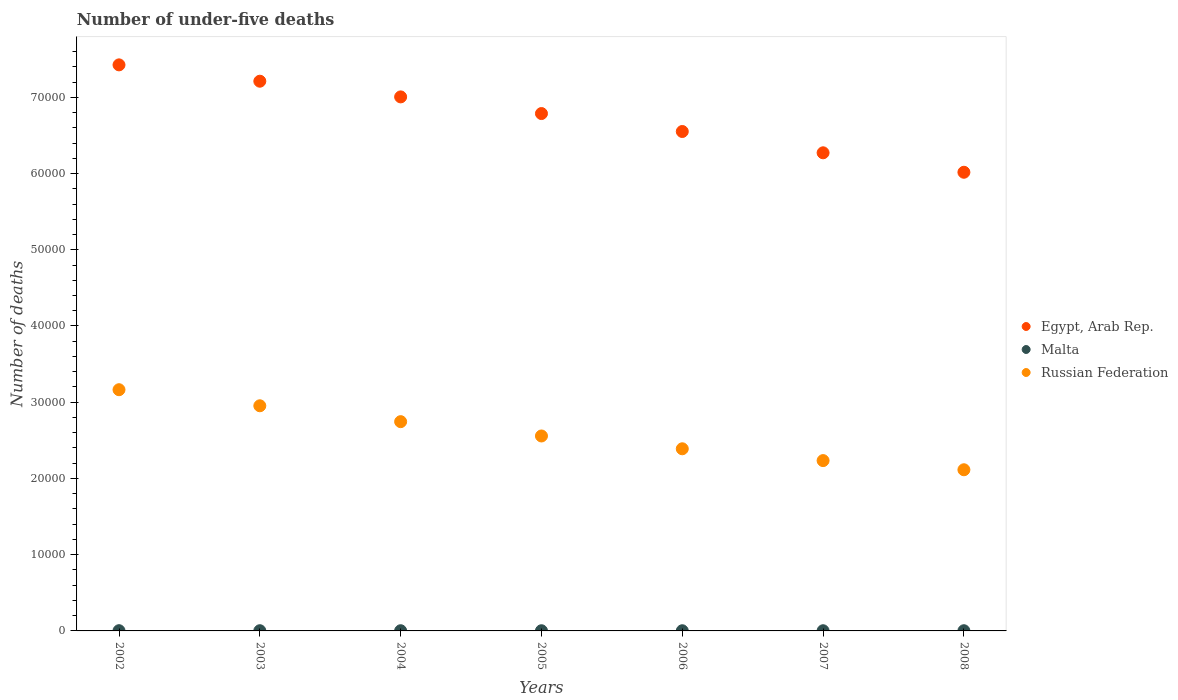How many different coloured dotlines are there?
Give a very brief answer. 3. What is the number of under-five deaths in Malta in 2007?
Make the answer very short. 24. Across all years, what is the maximum number of under-five deaths in Malta?
Your answer should be very brief. 31. Across all years, what is the minimum number of under-five deaths in Russian Federation?
Your response must be concise. 2.11e+04. In which year was the number of under-five deaths in Malta minimum?
Make the answer very short. 2006. What is the total number of under-five deaths in Malta in the graph?
Give a very brief answer. 180. What is the difference between the number of under-five deaths in Malta in 2003 and that in 2007?
Keep it short and to the point. 4. What is the difference between the number of under-five deaths in Egypt, Arab Rep. in 2002 and the number of under-five deaths in Russian Federation in 2007?
Make the answer very short. 5.19e+04. What is the average number of under-five deaths in Malta per year?
Keep it short and to the point. 25.71. In the year 2008, what is the difference between the number of under-five deaths in Malta and number of under-five deaths in Egypt, Arab Rep.?
Offer a terse response. -6.01e+04. What is the ratio of the number of under-five deaths in Malta in 2004 to that in 2007?
Ensure brevity in your answer.  1.04. What is the difference between the highest and the lowest number of under-five deaths in Egypt, Arab Rep.?
Provide a succinct answer. 1.41e+04. In how many years, is the number of under-five deaths in Egypt, Arab Rep. greater than the average number of under-five deaths in Egypt, Arab Rep. taken over all years?
Keep it short and to the point. 4. Does the number of under-five deaths in Malta monotonically increase over the years?
Keep it short and to the point. No. Is the number of under-five deaths in Malta strictly greater than the number of under-five deaths in Egypt, Arab Rep. over the years?
Ensure brevity in your answer.  No. Is the number of under-five deaths in Egypt, Arab Rep. strictly less than the number of under-five deaths in Malta over the years?
Your answer should be compact. No. What is the difference between two consecutive major ticks on the Y-axis?
Offer a very short reply. 10000. Are the values on the major ticks of Y-axis written in scientific E-notation?
Provide a short and direct response. No. Where does the legend appear in the graph?
Offer a very short reply. Center right. What is the title of the graph?
Offer a terse response. Number of under-five deaths. What is the label or title of the Y-axis?
Make the answer very short. Number of deaths. What is the Number of deaths in Egypt, Arab Rep. in 2002?
Offer a very short reply. 7.43e+04. What is the Number of deaths in Malta in 2002?
Provide a succinct answer. 31. What is the Number of deaths in Russian Federation in 2002?
Offer a very short reply. 3.16e+04. What is the Number of deaths in Egypt, Arab Rep. in 2003?
Make the answer very short. 7.21e+04. What is the Number of deaths of Russian Federation in 2003?
Keep it short and to the point. 2.95e+04. What is the Number of deaths in Egypt, Arab Rep. in 2004?
Keep it short and to the point. 7.01e+04. What is the Number of deaths in Malta in 2004?
Make the answer very short. 25. What is the Number of deaths in Russian Federation in 2004?
Offer a very short reply. 2.75e+04. What is the Number of deaths of Egypt, Arab Rep. in 2005?
Give a very brief answer. 6.79e+04. What is the Number of deaths of Malta in 2005?
Provide a succinct answer. 24. What is the Number of deaths in Russian Federation in 2005?
Provide a succinct answer. 2.56e+04. What is the Number of deaths of Egypt, Arab Rep. in 2006?
Your response must be concise. 6.55e+04. What is the Number of deaths in Russian Federation in 2006?
Keep it short and to the point. 2.39e+04. What is the Number of deaths of Egypt, Arab Rep. in 2007?
Your answer should be very brief. 6.27e+04. What is the Number of deaths in Russian Federation in 2007?
Keep it short and to the point. 2.23e+04. What is the Number of deaths of Egypt, Arab Rep. in 2008?
Your answer should be very brief. 6.02e+04. What is the Number of deaths of Russian Federation in 2008?
Your response must be concise. 2.11e+04. Across all years, what is the maximum Number of deaths in Egypt, Arab Rep.?
Keep it short and to the point. 7.43e+04. Across all years, what is the maximum Number of deaths of Russian Federation?
Offer a terse response. 3.16e+04. Across all years, what is the minimum Number of deaths of Egypt, Arab Rep.?
Make the answer very short. 6.02e+04. Across all years, what is the minimum Number of deaths in Russian Federation?
Keep it short and to the point. 2.11e+04. What is the total Number of deaths of Egypt, Arab Rep. in the graph?
Keep it short and to the point. 4.73e+05. What is the total Number of deaths of Malta in the graph?
Provide a succinct answer. 180. What is the total Number of deaths in Russian Federation in the graph?
Offer a terse response. 1.82e+05. What is the difference between the Number of deaths of Egypt, Arab Rep. in 2002 and that in 2003?
Keep it short and to the point. 2144. What is the difference between the Number of deaths in Russian Federation in 2002 and that in 2003?
Your answer should be very brief. 2108. What is the difference between the Number of deaths in Egypt, Arab Rep. in 2002 and that in 2004?
Your answer should be compact. 4201. What is the difference between the Number of deaths in Russian Federation in 2002 and that in 2004?
Your response must be concise. 4191. What is the difference between the Number of deaths of Egypt, Arab Rep. in 2002 and that in 2005?
Your answer should be compact. 6386. What is the difference between the Number of deaths of Malta in 2002 and that in 2005?
Provide a short and direct response. 7. What is the difference between the Number of deaths in Russian Federation in 2002 and that in 2005?
Give a very brief answer. 6069. What is the difference between the Number of deaths in Egypt, Arab Rep. in 2002 and that in 2006?
Your response must be concise. 8741. What is the difference between the Number of deaths in Russian Federation in 2002 and that in 2006?
Your answer should be compact. 7749. What is the difference between the Number of deaths of Egypt, Arab Rep. in 2002 and that in 2007?
Give a very brief answer. 1.15e+04. What is the difference between the Number of deaths in Malta in 2002 and that in 2007?
Offer a very short reply. 7. What is the difference between the Number of deaths in Russian Federation in 2002 and that in 2007?
Your response must be concise. 9299. What is the difference between the Number of deaths in Egypt, Arab Rep. in 2002 and that in 2008?
Provide a short and direct response. 1.41e+04. What is the difference between the Number of deaths in Russian Federation in 2002 and that in 2008?
Make the answer very short. 1.05e+04. What is the difference between the Number of deaths in Egypt, Arab Rep. in 2003 and that in 2004?
Provide a succinct answer. 2057. What is the difference between the Number of deaths in Russian Federation in 2003 and that in 2004?
Offer a terse response. 2083. What is the difference between the Number of deaths of Egypt, Arab Rep. in 2003 and that in 2005?
Provide a succinct answer. 4242. What is the difference between the Number of deaths in Russian Federation in 2003 and that in 2005?
Make the answer very short. 3961. What is the difference between the Number of deaths of Egypt, Arab Rep. in 2003 and that in 2006?
Offer a very short reply. 6597. What is the difference between the Number of deaths in Malta in 2003 and that in 2006?
Provide a short and direct response. 5. What is the difference between the Number of deaths in Russian Federation in 2003 and that in 2006?
Provide a succinct answer. 5641. What is the difference between the Number of deaths of Egypt, Arab Rep. in 2003 and that in 2007?
Your answer should be very brief. 9391. What is the difference between the Number of deaths of Malta in 2003 and that in 2007?
Give a very brief answer. 4. What is the difference between the Number of deaths in Russian Federation in 2003 and that in 2007?
Provide a succinct answer. 7191. What is the difference between the Number of deaths of Egypt, Arab Rep. in 2003 and that in 2008?
Your response must be concise. 1.19e+04. What is the difference between the Number of deaths in Russian Federation in 2003 and that in 2008?
Provide a succinct answer. 8393. What is the difference between the Number of deaths of Egypt, Arab Rep. in 2004 and that in 2005?
Your answer should be compact. 2185. What is the difference between the Number of deaths in Malta in 2004 and that in 2005?
Your response must be concise. 1. What is the difference between the Number of deaths in Russian Federation in 2004 and that in 2005?
Provide a short and direct response. 1878. What is the difference between the Number of deaths of Egypt, Arab Rep. in 2004 and that in 2006?
Your answer should be very brief. 4540. What is the difference between the Number of deaths in Russian Federation in 2004 and that in 2006?
Your answer should be compact. 3558. What is the difference between the Number of deaths in Egypt, Arab Rep. in 2004 and that in 2007?
Provide a short and direct response. 7334. What is the difference between the Number of deaths of Russian Federation in 2004 and that in 2007?
Offer a very short reply. 5108. What is the difference between the Number of deaths in Egypt, Arab Rep. in 2004 and that in 2008?
Your answer should be very brief. 9887. What is the difference between the Number of deaths in Malta in 2004 and that in 2008?
Your answer should be compact. 0. What is the difference between the Number of deaths of Russian Federation in 2004 and that in 2008?
Keep it short and to the point. 6310. What is the difference between the Number of deaths in Egypt, Arab Rep. in 2005 and that in 2006?
Your response must be concise. 2355. What is the difference between the Number of deaths of Russian Federation in 2005 and that in 2006?
Offer a terse response. 1680. What is the difference between the Number of deaths in Egypt, Arab Rep. in 2005 and that in 2007?
Offer a terse response. 5149. What is the difference between the Number of deaths of Malta in 2005 and that in 2007?
Give a very brief answer. 0. What is the difference between the Number of deaths in Russian Federation in 2005 and that in 2007?
Keep it short and to the point. 3230. What is the difference between the Number of deaths of Egypt, Arab Rep. in 2005 and that in 2008?
Make the answer very short. 7702. What is the difference between the Number of deaths in Russian Federation in 2005 and that in 2008?
Your response must be concise. 4432. What is the difference between the Number of deaths of Egypt, Arab Rep. in 2006 and that in 2007?
Your answer should be very brief. 2794. What is the difference between the Number of deaths of Malta in 2006 and that in 2007?
Offer a terse response. -1. What is the difference between the Number of deaths of Russian Federation in 2006 and that in 2007?
Offer a terse response. 1550. What is the difference between the Number of deaths of Egypt, Arab Rep. in 2006 and that in 2008?
Ensure brevity in your answer.  5347. What is the difference between the Number of deaths in Malta in 2006 and that in 2008?
Your answer should be compact. -2. What is the difference between the Number of deaths of Russian Federation in 2006 and that in 2008?
Give a very brief answer. 2752. What is the difference between the Number of deaths of Egypt, Arab Rep. in 2007 and that in 2008?
Your answer should be very brief. 2553. What is the difference between the Number of deaths of Russian Federation in 2007 and that in 2008?
Your response must be concise. 1202. What is the difference between the Number of deaths of Egypt, Arab Rep. in 2002 and the Number of deaths of Malta in 2003?
Keep it short and to the point. 7.42e+04. What is the difference between the Number of deaths of Egypt, Arab Rep. in 2002 and the Number of deaths of Russian Federation in 2003?
Offer a very short reply. 4.47e+04. What is the difference between the Number of deaths of Malta in 2002 and the Number of deaths of Russian Federation in 2003?
Provide a succinct answer. -2.95e+04. What is the difference between the Number of deaths in Egypt, Arab Rep. in 2002 and the Number of deaths in Malta in 2004?
Offer a very short reply. 7.42e+04. What is the difference between the Number of deaths of Egypt, Arab Rep. in 2002 and the Number of deaths of Russian Federation in 2004?
Keep it short and to the point. 4.68e+04. What is the difference between the Number of deaths of Malta in 2002 and the Number of deaths of Russian Federation in 2004?
Your response must be concise. -2.74e+04. What is the difference between the Number of deaths of Egypt, Arab Rep. in 2002 and the Number of deaths of Malta in 2005?
Offer a very short reply. 7.42e+04. What is the difference between the Number of deaths of Egypt, Arab Rep. in 2002 and the Number of deaths of Russian Federation in 2005?
Your response must be concise. 4.87e+04. What is the difference between the Number of deaths of Malta in 2002 and the Number of deaths of Russian Federation in 2005?
Give a very brief answer. -2.55e+04. What is the difference between the Number of deaths of Egypt, Arab Rep. in 2002 and the Number of deaths of Malta in 2006?
Offer a very short reply. 7.42e+04. What is the difference between the Number of deaths of Egypt, Arab Rep. in 2002 and the Number of deaths of Russian Federation in 2006?
Offer a terse response. 5.04e+04. What is the difference between the Number of deaths of Malta in 2002 and the Number of deaths of Russian Federation in 2006?
Your response must be concise. -2.39e+04. What is the difference between the Number of deaths in Egypt, Arab Rep. in 2002 and the Number of deaths in Malta in 2007?
Your response must be concise. 7.42e+04. What is the difference between the Number of deaths in Egypt, Arab Rep. in 2002 and the Number of deaths in Russian Federation in 2007?
Ensure brevity in your answer.  5.19e+04. What is the difference between the Number of deaths in Malta in 2002 and the Number of deaths in Russian Federation in 2007?
Offer a very short reply. -2.23e+04. What is the difference between the Number of deaths of Egypt, Arab Rep. in 2002 and the Number of deaths of Malta in 2008?
Your answer should be very brief. 7.42e+04. What is the difference between the Number of deaths of Egypt, Arab Rep. in 2002 and the Number of deaths of Russian Federation in 2008?
Your answer should be very brief. 5.31e+04. What is the difference between the Number of deaths in Malta in 2002 and the Number of deaths in Russian Federation in 2008?
Your answer should be compact. -2.11e+04. What is the difference between the Number of deaths of Egypt, Arab Rep. in 2003 and the Number of deaths of Malta in 2004?
Provide a short and direct response. 7.21e+04. What is the difference between the Number of deaths in Egypt, Arab Rep. in 2003 and the Number of deaths in Russian Federation in 2004?
Ensure brevity in your answer.  4.47e+04. What is the difference between the Number of deaths of Malta in 2003 and the Number of deaths of Russian Federation in 2004?
Offer a terse response. -2.74e+04. What is the difference between the Number of deaths of Egypt, Arab Rep. in 2003 and the Number of deaths of Malta in 2005?
Make the answer very short. 7.21e+04. What is the difference between the Number of deaths in Egypt, Arab Rep. in 2003 and the Number of deaths in Russian Federation in 2005?
Make the answer very short. 4.65e+04. What is the difference between the Number of deaths of Malta in 2003 and the Number of deaths of Russian Federation in 2005?
Your response must be concise. -2.55e+04. What is the difference between the Number of deaths of Egypt, Arab Rep. in 2003 and the Number of deaths of Malta in 2006?
Make the answer very short. 7.21e+04. What is the difference between the Number of deaths of Egypt, Arab Rep. in 2003 and the Number of deaths of Russian Federation in 2006?
Offer a very short reply. 4.82e+04. What is the difference between the Number of deaths in Malta in 2003 and the Number of deaths in Russian Federation in 2006?
Give a very brief answer. -2.39e+04. What is the difference between the Number of deaths in Egypt, Arab Rep. in 2003 and the Number of deaths in Malta in 2007?
Make the answer very short. 7.21e+04. What is the difference between the Number of deaths in Egypt, Arab Rep. in 2003 and the Number of deaths in Russian Federation in 2007?
Your response must be concise. 4.98e+04. What is the difference between the Number of deaths in Malta in 2003 and the Number of deaths in Russian Federation in 2007?
Provide a short and direct response. -2.23e+04. What is the difference between the Number of deaths of Egypt, Arab Rep. in 2003 and the Number of deaths of Malta in 2008?
Ensure brevity in your answer.  7.21e+04. What is the difference between the Number of deaths in Egypt, Arab Rep. in 2003 and the Number of deaths in Russian Federation in 2008?
Your response must be concise. 5.10e+04. What is the difference between the Number of deaths in Malta in 2003 and the Number of deaths in Russian Federation in 2008?
Ensure brevity in your answer.  -2.11e+04. What is the difference between the Number of deaths in Egypt, Arab Rep. in 2004 and the Number of deaths in Malta in 2005?
Give a very brief answer. 7.00e+04. What is the difference between the Number of deaths of Egypt, Arab Rep. in 2004 and the Number of deaths of Russian Federation in 2005?
Your answer should be very brief. 4.45e+04. What is the difference between the Number of deaths of Malta in 2004 and the Number of deaths of Russian Federation in 2005?
Your answer should be very brief. -2.55e+04. What is the difference between the Number of deaths of Egypt, Arab Rep. in 2004 and the Number of deaths of Malta in 2006?
Offer a very short reply. 7.00e+04. What is the difference between the Number of deaths in Egypt, Arab Rep. in 2004 and the Number of deaths in Russian Federation in 2006?
Make the answer very short. 4.62e+04. What is the difference between the Number of deaths in Malta in 2004 and the Number of deaths in Russian Federation in 2006?
Give a very brief answer. -2.39e+04. What is the difference between the Number of deaths of Egypt, Arab Rep. in 2004 and the Number of deaths of Malta in 2007?
Keep it short and to the point. 7.00e+04. What is the difference between the Number of deaths in Egypt, Arab Rep. in 2004 and the Number of deaths in Russian Federation in 2007?
Your answer should be very brief. 4.77e+04. What is the difference between the Number of deaths in Malta in 2004 and the Number of deaths in Russian Federation in 2007?
Your response must be concise. -2.23e+04. What is the difference between the Number of deaths of Egypt, Arab Rep. in 2004 and the Number of deaths of Malta in 2008?
Your answer should be compact. 7.00e+04. What is the difference between the Number of deaths of Egypt, Arab Rep. in 2004 and the Number of deaths of Russian Federation in 2008?
Offer a terse response. 4.89e+04. What is the difference between the Number of deaths in Malta in 2004 and the Number of deaths in Russian Federation in 2008?
Provide a succinct answer. -2.11e+04. What is the difference between the Number of deaths in Egypt, Arab Rep. in 2005 and the Number of deaths in Malta in 2006?
Give a very brief answer. 6.78e+04. What is the difference between the Number of deaths in Egypt, Arab Rep. in 2005 and the Number of deaths in Russian Federation in 2006?
Your answer should be compact. 4.40e+04. What is the difference between the Number of deaths of Malta in 2005 and the Number of deaths of Russian Federation in 2006?
Your answer should be compact. -2.39e+04. What is the difference between the Number of deaths of Egypt, Arab Rep. in 2005 and the Number of deaths of Malta in 2007?
Offer a very short reply. 6.78e+04. What is the difference between the Number of deaths of Egypt, Arab Rep. in 2005 and the Number of deaths of Russian Federation in 2007?
Keep it short and to the point. 4.55e+04. What is the difference between the Number of deaths of Malta in 2005 and the Number of deaths of Russian Federation in 2007?
Your response must be concise. -2.23e+04. What is the difference between the Number of deaths of Egypt, Arab Rep. in 2005 and the Number of deaths of Malta in 2008?
Provide a succinct answer. 6.78e+04. What is the difference between the Number of deaths of Egypt, Arab Rep. in 2005 and the Number of deaths of Russian Federation in 2008?
Offer a very short reply. 4.67e+04. What is the difference between the Number of deaths in Malta in 2005 and the Number of deaths in Russian Federation in 2008?
Offer a terse response. -2.11e+04. What is the difference between the Number of deaths in Egypt, Arab Rep. in 2006 and the Number of deaths in Malta in 2007?
Offer a very short reply. 6.55e+04. What is the difference between the Number of deaths in Egypt, Arab Rep. in 2006 and the Number of deaths in Russian Federation in 2007?
Offer a terse response. 4.32e+04. What is the difference between the Number of deaths of Malta in 2006 and the Number of deaths of Russian Federation in 2007?
Offer a very short reply. -2.23e+04. What is the difference between the Number of deaths of Egypt, Arab Rep. in 2006 and the Number of deaths of Malta in 2008?
Ensure brevity in your answer.  6.55e+04. What is the difference between the Number of deaths of Egypt, Arab Rep. in 2006 and the Number of deaths of Russian Federation in 2008?
Ensure brevity in your answer.  4.44e+04. What is the difference between the Number of deaths in Malta in 2006 and the Number of deaths in Russian Federation in 2008?
Provide a short and direct response. -2.11e+04. What is the difference between the Number of deaths of Egypt, Arab Rep. in 2007 and the Number of deaths of Malta in 2008?
Keep it short and to the point. 6.27e+04. What is the difference between the Number of deaths of Egypt, Arab Rep. in 2007 and the Number of deaths of Russian Federation in 2008?
Your answer should be compact. 4.16e+04. What is the difference between the Number of deaths of Malta in 2007 and the Number of deaths of Russian Federation in 2008?
Ensure brevity in your answer.  -2.11e+04. What is the average Number of deaths of Egypt, Arab Rep. per year?
Give a very brief answer. 6.75e+04. What is the average Number of deaths of Malta per year?
Make the answer very short. 25.71. What is the average Number of deaths in Russian Federation per year?
Provide a short and direct response. 2.59e+04. In the year 2002, what is the difference between the Number of deaths in Egypt, Arab Rep. and Number of deaths in Malta?
Provide a succinct answer. 7.42e+04. In the year 2002, what is the difference between the Number of deaths of Egypt, Arab Rep. and Number of deaths of Russian Federation?
Offer a terse response. 4.26e+04. In the year 2002, what is the difference between the Number of deaths of Malta and Number of deaths of Russian Federation?
Your response must be concise. -3.16e+04. In the year 2003, what is the difference between the Number of deaths of Egypt, Arab Rep. and Number of deaths of Malta?
Make the answer very short. 7.21e+04. In the year 2003, what is the difference between the Number of deaths in Egypt, Arab Rep. and Number of deaths in Russian Federation?
Your response must be concise. 4.26e+04. In the year 2003, what is the difference between the Number of deaths in Malta and Number of deaths in Russian Federation?
Your response must be concise. -2.95e+04. In the year 2004, what is the difference between the Number of deaths in Egypt, Arab Rep. and Number of deaths in Malta?
Keep it short and to the point. 7.00e+04. In the year 2004, what is the difference between the Number of deaths of Egypt, Arab Rep. and Number of deaths of Russian Federation?
Keep it short and to the point. 4.26e+04. In the year 2004, what is the difference between the Number of deaths in Malta and Number of deaths in Russian Federation?
Your answer should be compact. -2.74e+04. In the year 2005, what is the difference between the Number of deaths of Egypt, Arab Rep. and Number of deaths of Malta?
Offer a very short reply. 6.78e+04. In the year 2005, what is the difference between the Number of deaths in Egypt, Arab Rep. and Number of deaths in Russian Federation?
Offer a terse response. 4.23e+04. In the year 2005, what is the difference between the Number of deaths in Malta and Number of deaths in Russian Federation?
Your response must be concise. -2.55e+04. In the year 2006, what is the difference between the Number of deaths in Egypt, Arab Rep. and Number of deaths in Malta?
Your response must be concise. 6.55e+04. In the year 2006, what is the difference between the Number of deaths of Egypt, Arab Rep. and Number of deaths of Russian Federation?
Give a very brief answer. 4.16e+04. In the year 2006, what is the difference between the Number of deaths in Malta and Number of deaths in Russian Federation?
Keep it short and to the point. -2.39e+04. In the year 2007, what is the difference between the Number of deaths of Egypt, Arab Rep. and Number of deaths of Malta?
Offer a very short reply. 6.27e+04. In the year 2007, what is the difference between the Number of deaths in Egypt, Arab Rep. and Number of deaths in Russian Federation?
Make the answer very short. 4.04e+04. In the year 2007, what is the difference between the Number of deaths of Malta and Number of deaths of Russian Federation?
Your response must be concise. -2.23e+04. In the year 2008, what is the difference between the Number of deaths of Egypt, Arab Rep. and Number of deaths of Malta?
Make the answer very short. 6.01e+04. In the year 2008, what is the difference between the Number of deaths in Egypt, Arab Rep. and Number of deaths in Russian Federation?
Make the answer very short. 3.90e+04. In the year 2008, what is the difference between the Number of deaths in Malta and Number of deaths in Russian Federation?
Your answer should be very brief. -2.11e+04. What is the ratio of the Number of deaths of Egypt, Arab Rep. in 2002 to that in 2003?
Your response must be concise. 1.03. What is the ratio of the Number of deaths in Malta in 2002 to that in 2003?
Your answer should be very brief. 1.11. What is the ratio of the Number of deaths in Russian Federation in 2002 to that in 2003?
Ensure brevity in your answer.  1.07. What is the ratio of the Number of deaths of Egypt, Arab Rep. in 2002 to that in 2004?
Give a very brief answer. 1.06. What is the ratio of the Number of deaths of Malta in 2002 to that in 2004?
Provide a succinct answer. 1.24. What is the ratio of the Number of deaths in Russian Federation in 2002 to that in 2004?
Your response must be concise. 1.15. What is the ratio of the Number of deaths in Egypt, Arab Rep. in 2002 to that in 2005?
Give a very brief answer. 1.09. What is the ratio of the Number of deaths of Malta in 2002 to that in 2005?
Offer a terse response. 1.29. What is the ratio of the Number of deaths in Russian Federation in 2002 to that in 2005?
Provide a succinct answer. 1.24. What is the ratio of the Number of deaths in Egypt, Arab Rep. in 2002 to that in 2006?
Offer a very short reply. 1.13. What is the ratio of the Number of deaths in Malta in 2002 to that in 2006?
Offer a very short reply. 1.35. What is the ratio of the Number of deaths of Russian Federation in 2002 to that in 2006?
Keep it short and to the point. 1.32. What is the ratio of the Number of deaths in Egypt, Arab Rep. in 2002 to that in 2007?
Offer a terse response. 1.18. What is the ratio of the Number of deaths in Malta in 2002 to that in 2007?
Your response must be concise. 1.29. What is the ratio of the Number of deaths in Russian Federation in 2002 to that in 2007?
Ensure brevity in your answer.  1.42. What is the ratio of the Number of deaths of Egypt, Arab Rep. in 2002 to that in 2008?
Ensure brevity in your answer.  1.23. What is the ratio of the Number of deaths in Malta in 2002 to that in 2008?
Your answer should be very brief. 1.24. What is the ratio of the Number of deaths in Russian Federation in 2002 to that in 2008?
Your response must be concise. 1.5. What is the ratio of the Number of deaths in Egypt, Arab Rep. in 2003 to that in 2004?
Keep it short and to the point. 1.03. What is the ratio of the Number of deaths in Malta in 2003 to that in 2004?
Give a very brief answer. 1.12. What is the ratio of the Number of deaths in Russian Federation in 2003 to that in 2004?
Your answer should be very brief. 1.08. What is the ratio of the Number of deaths of Malta in 2003 to that in 2005?
Keep it short and to the point. 1.17. What is the ratio of the Number of deaths in Russian Federation in 2003 to that in 2005?
Your answer should be very brief. 1.15. What is the ratio of the Number of deaths of Egypt, Arab Rep. in 2003 to that in 2006?
Provide a short and direct response. 1.1. What is the ratio of the Number of deaths of Malta in 2003 to that in 2006?
Your response must be concise. 1.22. What is the ratio of the Number of deaths in Russian Federation in 2003 to that in 2006?
Keep it short and to the point. 1.24. What is the ratio of the Number of deaths in Egypt, Arab Rep. in 2003 to that in 2007?
Give a very brief answer. 1.15. What is the ratio of the Number of deaths of Malta in 2003 to that in 2007?
Ensure brevity in your answer.  1.17. What is the ratio of the Number of deaths in Russian Federation in 2003 to that in 2007?
Ensure brevity in your answer.  1.32. What is the ratio of the Number of deaths in Egypt, Arab Rep. in 2003 to that in 2008?
Offer a terse response. 1.2. What is the ratio of the Number of deaths in Malta in 2003 to that in 2008?
Offer a terse response. 1.12. What is the ratio of the Number of deaths of Russian Federation in 2003 to that in 2008?
Provide a succinct answer. 1.4. What is the ratio of the Number of deaths in Egypt, Arab Rep. in 2004 to that in 2005?
Give a very brief answer. 1.03. What is the ratio of the Number of deaths in Malta in 2004 to that in 2005?
Your answer should be very brief. 1.04. What is the ratio of the Number of deaths in Russian Federation in 2004 to that in 2005?
Keep it short and to the point. 1.07. What is the ratio of the Number of deaths in Egypt, Arab Rep. in 2004 to that in 2006?
Give a very brief answer. 1.07. What is the ratio of the Number of deaths in Malta in 2004 to that in 2006?
Give a very brief answer. 1.09. What is the ratio of the Number of deaths in Russian Federation in 2004 to that in 2006?
Offer a very short reply. 1.15. What is the ratio of the Number of deaths in Egypt, Arab Rep. in 2004 to that in 2007?
Keep it short and to the point. 1.12. What is the ratio of the Number of deaths of Malta in 2004 to that in 2007?
Your response must be concise. 1.04. What is the ratio of the Number of deaths in Russian Federation in 2004 to that in 2007?
Your answer should be very brief. 1.23. What is the ratio of the Number of deaths of Egypt, Arab Rep. in 2004 to that in 2008?
Your answer should be compact. 1.16. What is the ratio of the Number of deaths of Malta in 2004 to that in 2008?
Your response must be concise. 1. What is the ratio of the Number of deaths of Russian Federation in 2004 to that in 2008?
Your answer should be very brief. 1.3. What is the ratio of the Number of deaths of Egypt, Arab Rep. in 2005 to that in 2006?
Give a very brief answer. 1.04. What is the ratio of the Number of deaths in Malta in 2005 to that in 2006?
Give a very brief answer. 1.04. What is the ratio of the Number of deaths of Russian Federation in 2005 to that in 2006?
Make the answer very short. 1.07. What is the ratio of the Number of deaths in Egypt, Arab Rep. in 2005 to that in 2007?
Offer a very short reply. 1.08. What is the ratio of the Number of deaths of Malta in 2005 to that in 2007?
Ensure brevity in your answer.  1. What is the ratio of the Number of deaths in Russian Federation in 2005 to that in 2007?
Offer a very short reply. 1.14. What is the ratio of the Number of deaths in Egypt, Arab Rep. in 2005 to that in 2008?
Provide a short and direct response. 1.13. What is the ratio of the Number of deaths of Russian Federation in 2005 to that in 2008?
Your response must be concise. 1.21. What is the ratio of the Number of deaths of Egypt, Arab Rep. in 2006 to that in 2007?
Give a very brief answer. 1.04. What is the ratio of the Number of deaths of Malta in 2006 to that in 2007?
Your answer should be very brief. 0.96. What is the ratio of the Number of deaths of Russian Federation in 2006 to that in 2007?
Offer a terse response. 1.07. What is the ratio of the Number of deaths in Egypt, Arab Rep. in 2006 to that in 2008?
Offer a terse response. 1.09. What is the ratio of the Number of deaths in Russian Federation in 2006 to that in 2008?
Ensure brevity in your answer.  1.13. What is the ratio of the Number of deaths in Egypt, Arab Rep. in 2007 to that in 2008?
Provide a short and direct response. 1.04. What is the ratio of the Number of deaths in Malta in 2007 to that in 2008?
Give a very brief answer. 0.96. What is the ratio of the Number of deaths in Russian Federation in 2007 to that in 2008?
Give a very brief answer. 1.06. What is the difference between the highest and the second highest Number of deaths in Egypt, Arab Rep.?
Your answer should be compact. 2144. What is the difference between the highest and the second highest Number of deaths in Malta?
Provide a short and direct response. 3. What is the difference between the highest and the second highest Number of deaths in Russian Federation?
Your response must be concise. 2108. What is the difference between the highest and the lowest Number of deaths of Egypt, Arab Rep.?
Offer a very short reply. 1.41e+04. What is the difference between the highest and the lowest Number of deaths of Malta?
Make the answer very short. 8. What is the difference between the highest and the lowest Number of deaths of Russian Federation?
Offer a very short reply. 1.05e+04. 